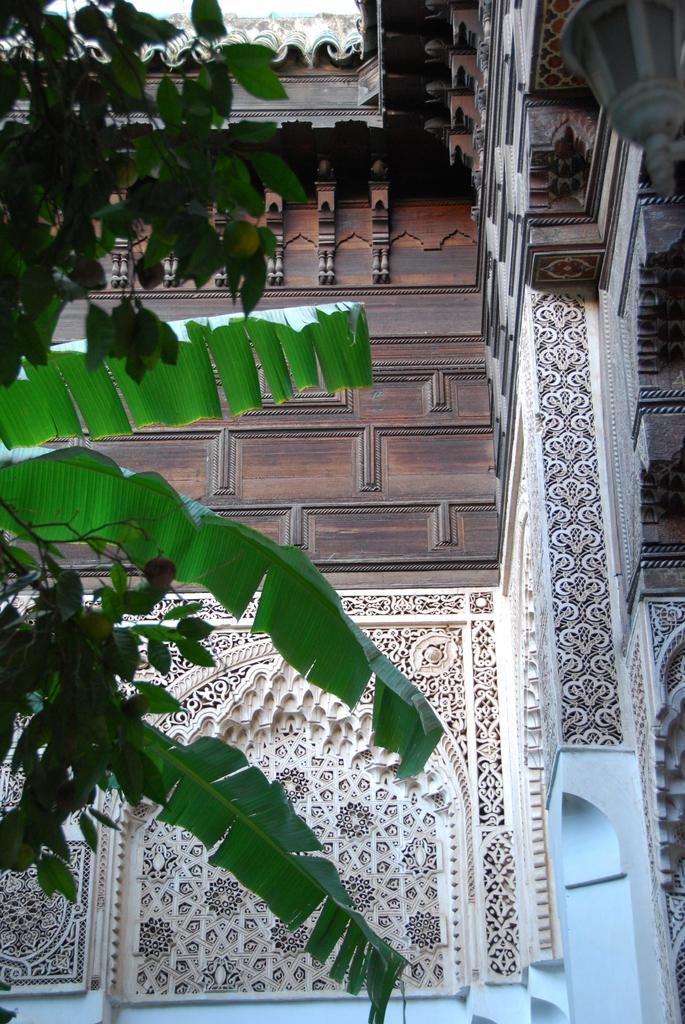Where was the picture taken? The picture was clicked outside. What type of vegetation can be seen on the left side of the image? There are green leaves on the left side of the image. What can be seen in the background of the image? There is a building and some art on the wall in the background of the image. Can you describe any other items visible in the image? There are other unspecified items visible in the image. How many caps are visible on the tree in the image? There is no tree or cap present in the image. What type of sorting is being done in the image? There is no sorting activity depicted in the image. 